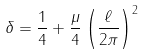<formula> <loc_0><loc_0><loc_500><loc_500>\delta = \frac { 1 } { 4 } + \frac { \mu } { 4 } \left ( \frac { \ell } { 2 \pi } \right ) ^ { 2 }</formula> 